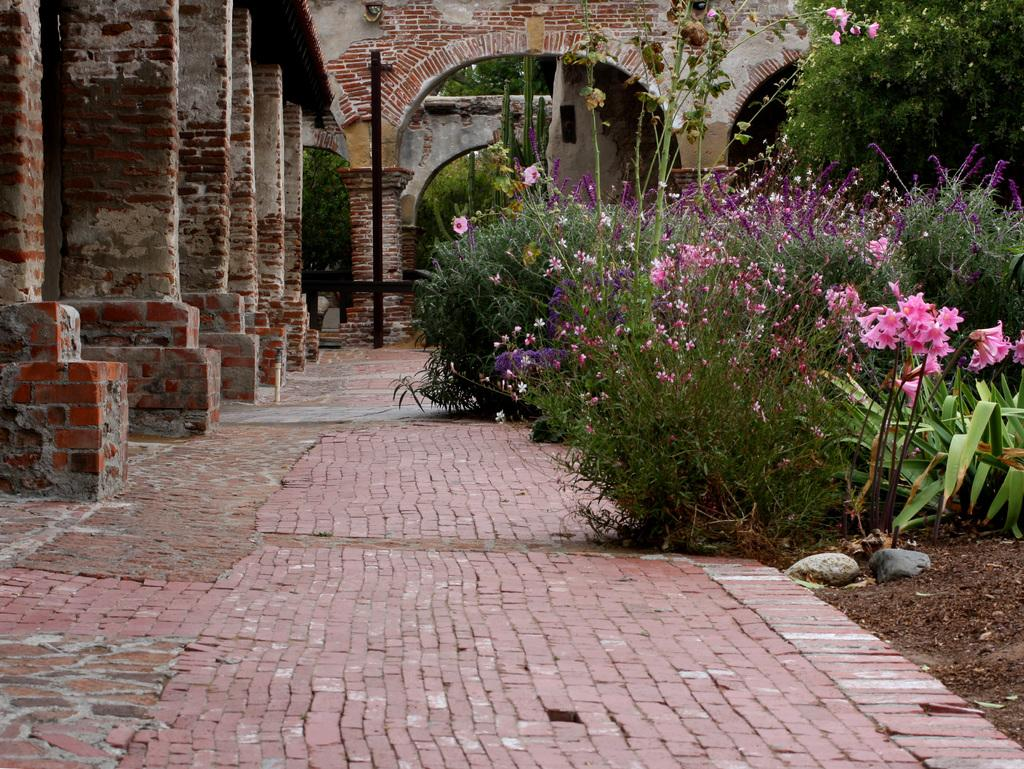What types of living organisms can be seen in the image? Plants and flowers are visible in the image. What is located at the right bottom of the image? There is soil at the right bottom of the image. What architectural features are present on the left side of the image? There are pillars on the left side of the image. What can be seen in the background of the image? There is a wall in the background of the image. Can you tell me how many owls are perched on the pillars in the image? There are no owls present in the image; it features plants, flowers, soil, pillars, and a wall. What type of sack is being used to carry the flowers in the image? There is no sack visible in the image; the flowers are not being carried or transported. 